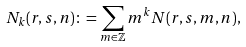<formula> <loc_0><loc_0><loc_500><loc_500>N _ { k } ( r , s , n ) \colon = \sum _ { m \in \mathbb { Z } } m ^ { k } N ( r , s , m , n ) ,</formula> 